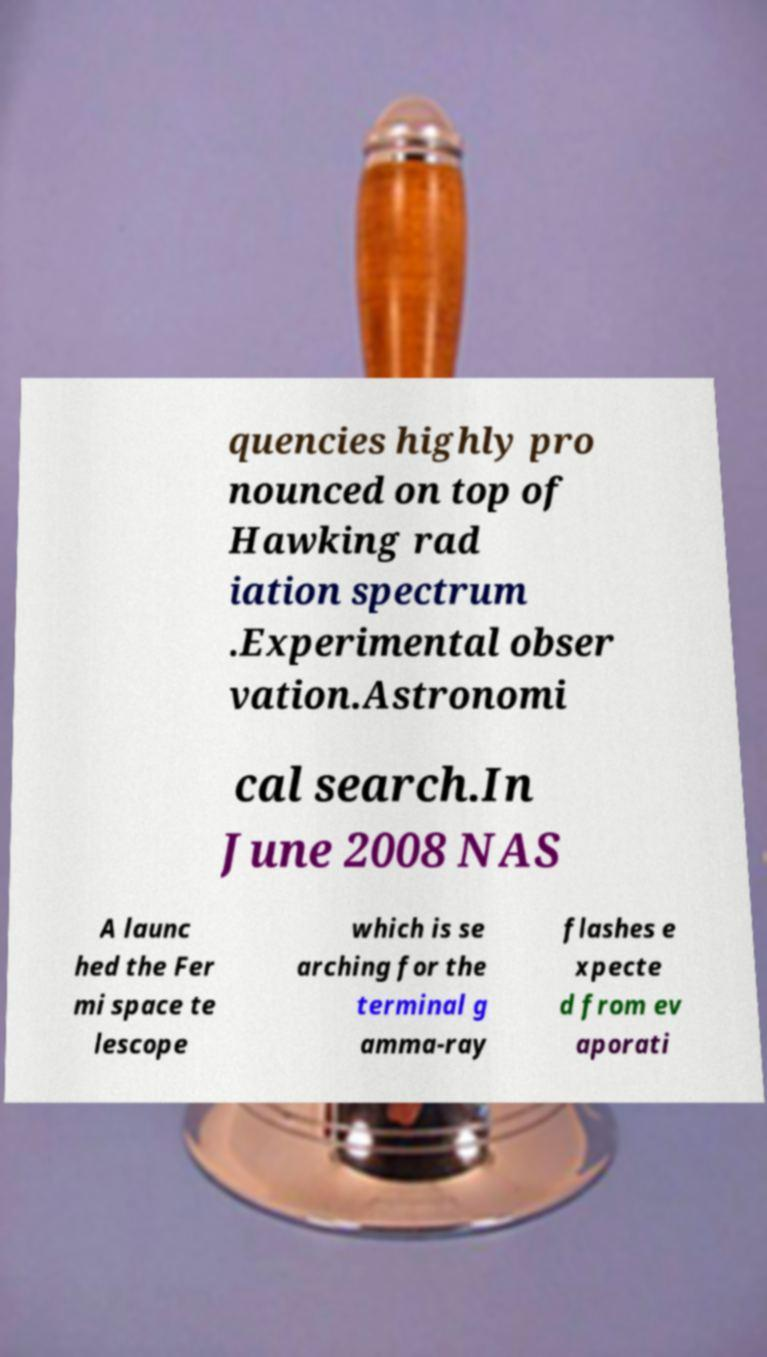For documentation purposes, I need the text within this image transcribed. Could you provide that? quencies highly pro nounced on top of Hawking rad iation spectrum .Experimental obser vation.Astronomi cal search.In June 2008 NAS A launc hed the Fer mi space te lescope which is se arching for the terminal g amma-ray flashes e xpecte d from ev aporati 